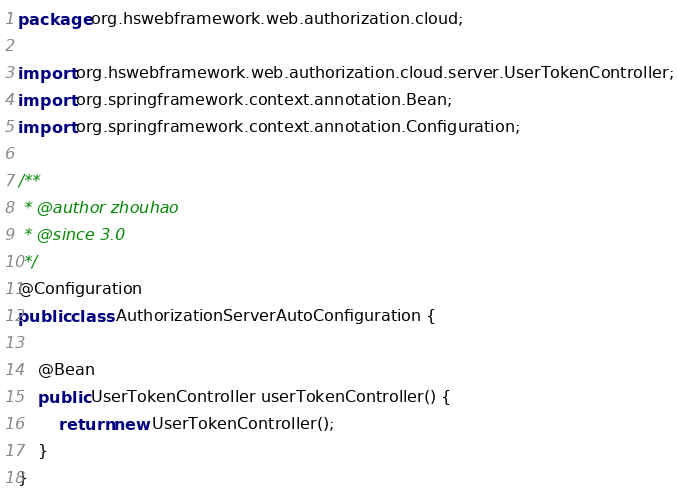<code> <loc_0><loc_0><loc_500><loc_500><_Java_>package org.hswebframework.web.authorization.cloud;

import org.hswebframework.web.authorization.cloud.server.UserTokenController;
import org.springframework.context.annotation.Bean;
import org.springframework.context.annotation.Configuration;

/**
 * @author zhouhao
 * @since 3.0
 */
@Configuration
public class AuthorizationServerAutoConfiguration {

    @Bean
    public UserTokenController userTokenController() {
        return new UserTokenController();
    }
}
</code> 